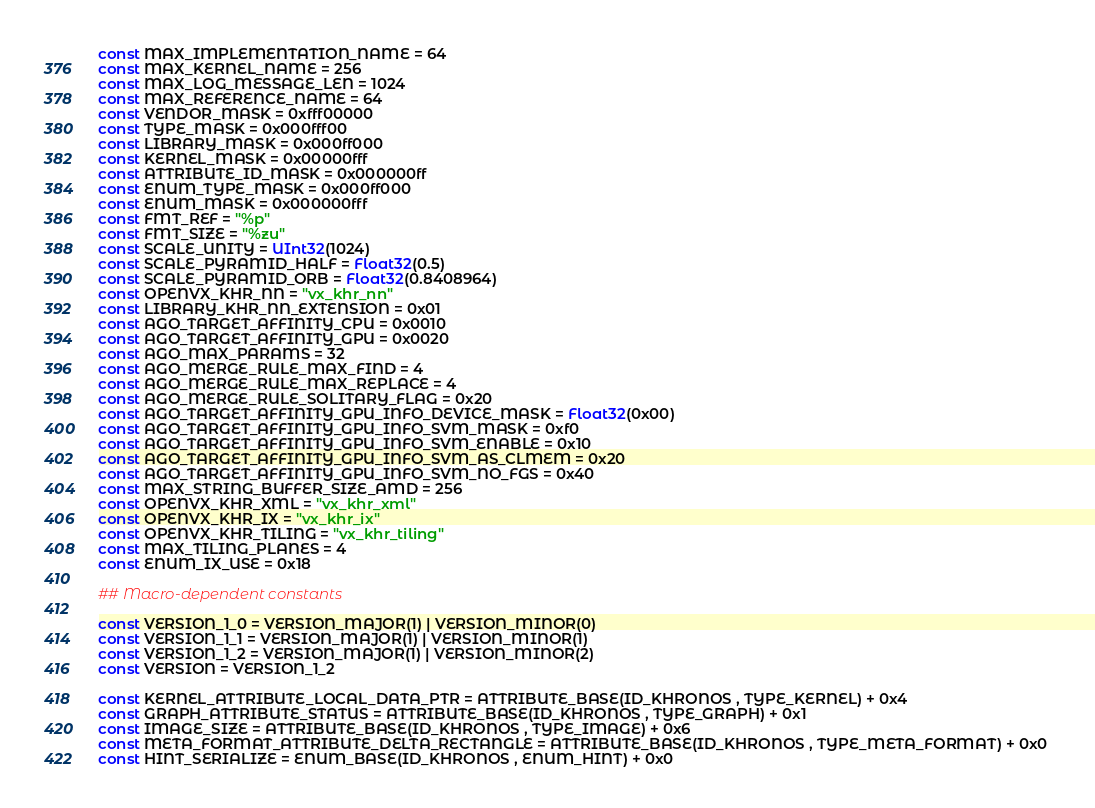<code> <loc_0><loc_0><loc_500><loc_500><_Julia_>const MAX_IMPLEMENTATION_NAME = 64
const MAX_KERNEL_NAME = 256
const MAX_LOG_MESSAGE_LEN = 1024
const MAX_REFERENCE_NAME = 64
const VENDOR_MASK = 0xfff00000
const TYPE_MASK = 0x000fff00
const LIBRARY_MASK = 0x000ff000
const KERNEL_MASK = 0x00000fff
const ATTRIBUTE_ID_MASK = 0x000000ff
const ENUM_TYPE_MASK = 0x000ff000
const ENUM_MASK = 0x000000fff
const FMT_REF = "%p"
const FMT_SIZE = "%zu"
const SCALE_UNITY = UInt32(1024)
const SCALE_PYRAMID_HALF = Float32(0.5)
const SCALE_PYRAMID_ORB = Float32(0.8408964)
const OPENVX_KHR_NN = "vx_khr_nn"
const LIBRARY_KHR_NN_EXTENSION = 0x01
const AGO_TARGET_AFFINITY_CPU = 0x0010
const AGO_TARGET_AFFINITY_GPU = 0x0020
const AGO_MAX_PARAMS = 32
const AGO_MERGE_RULE_MAX_FIND = 4
const AGO_MERGE_RULE_MAX_REPLACE = 4
const AGO_MERGE_RULE_SOLITARY_FLAG = 0x20
const AGO_TARGET_AFFINITY_GPU_INFO_DEVICE_MASK = Float32(0x00)
const AGO_TARGET_AFFINITY_GPU_INFO_SVM_MASK = 0xf0
const AGO_TARGET_AFFINITY_GPU_INFO_SVM_ENABLE = 0x10
const AGO_TARGET_AFFINITY_GPU_INFO_SVM_AS_CLMEM = 0x20
const AGO_TARGET_AFFINITY_GPU_INFO_SVM_NO_FGS = 0x40
const MAX_STRING_BUFFER_SIZE_AMD = 256
const OPENVX_KHR_XML = "vx_khr_xml"
const OPENVX_KHR_IX = "vx_khr_ix"
const OPENVX_KHR_TILING = "vx_khr_tiling"
const MAX_TILING_PLANES = 4
const ENUM_IX_USE = 0x18

## Macro-dependent constants

const VERSION_1_0 = VERSION_MAJOR(1) | VERSION_MINOR(0)
const VERSION_1_1 = VERSION_MAJOR(1) | VERSION_MINOR(1)
const VERSION_1_2 = VERSION_MAJOR(1) | VERSION_MINOR(2)
const VERSION = VERSION_1_2

const KERNEL_ATTRIBUTE_LOCAL_DATA_PTR = ATTRIBUTE_BASE(ID_KHRONOS , TYPE_KERNEL) + 0x4 
const GRAPH_ATTRIBUTE_STATUS = ATTRIBUTE_BASE(ID_KHRONOS , TYPE_GRAPH) + 0x1 
const IMAGE_SIZE = ATTRIBUTE_BASE(ID_KHRONOS , TYPE_IMAGE) + 0x6 
const META_FORMAT_ATTRIBUTE_DELTA_RECTANGLE = ATTRIBUTE_BASE(ID_KHRONOS , TYPE_META_FORMAT) + 0x0 
const HINT_SERIALIZE = ENUM_BASE(ID_KHRONOS , ENUM_HINT) + 0x0 </code> 